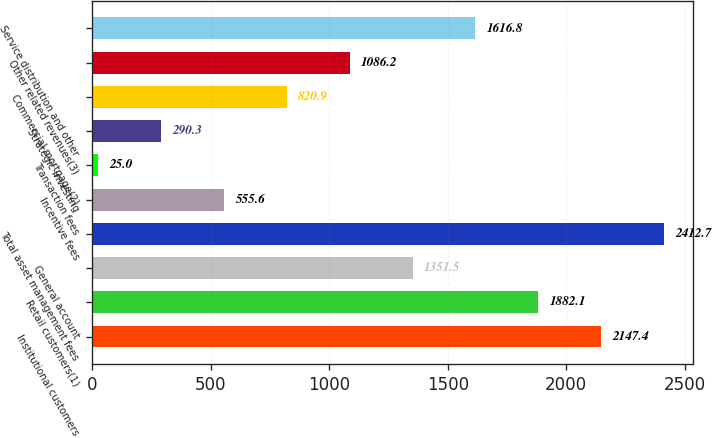Convert chart. <chart><loc_0><loc_0><loc_500><loc_500><bar_chart><fcel>Institutional customers<fcel>Retail customers(1)<fcel>General account<fcel>Total asset management fees<fcel>Incentive fees<fcel>Transaction fees<fcel>Strategic investing<fcel>Commercial mortgage(2)<fcel>Other related revenues(3)<fcel>Service distribution and other<nl><fcel>2147.4<fcel>1882.1<fcel>1351.5<fcel>2412.7<fcel>555.6<fcel>25<fcel>290.3<fcel>820.9<fcel>1086.2<fcel>1616.8<nl></chart> 